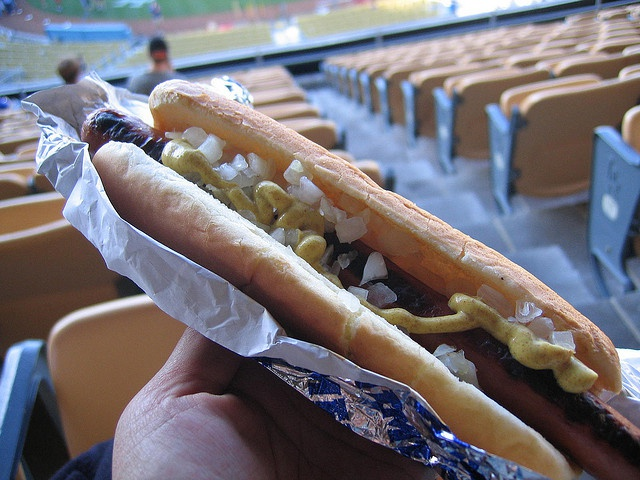Describe the objects in this image and their specific colors. I can see hot dog in blue, black, brown, lightgray, and gray tones, people in blue, black, darkgray, and gray tones, and people in blue and gray tones in this image. 